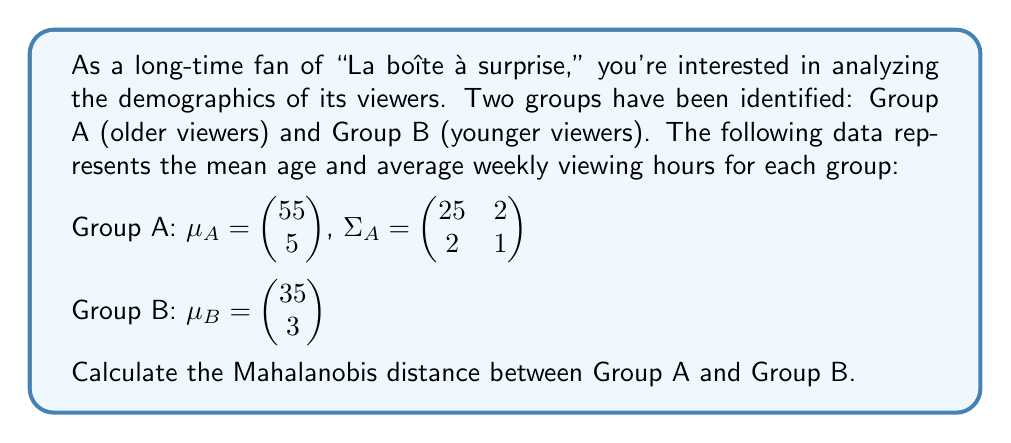Can you solve this math problem? To calculate the Mahalanobis distance between two groups, we'll follow these steps:

1) The Mahalanobis distance formula is:
   $$D_M = \sqrt{(\mu_A - \mu_B)^T \Sigma_A^{-1} (\mu_A - \mu_B)}$$

2) First, calculate $(\mu_A - \mu_B)$:
   $$\mu_A - \mu_B = \begin{pmatrix} 55 \\ 5 \end{pmatrix} - \begin{pmatrix} 35 \\ 3 \end{pmatrix} = \begin{pmatrix} 20 \\ 2 \end{pmatrix}$$

3) Next, we need to find $\Sigma_A^{-1}$. For a 2x2 matrix $\begin{pmatrix} a & b \\ c & d \end{pmatrix}$, the inverse is:
   $$\frac{1}{ad-bc} \begin{pmatrix} d & -b \\ -c & a \end{pmatrix}$$

   So, $\Sigma_A^{-1} = \frac{1}{25-4} \begin{pmatrix} 1 & -2 \\ -2 & 25 \end{pmatrix} = \frac{1}{21} \begin{pmatrix} 1 & -2 \\ -2 & 25 \end{pmatrix}$

4) Now, calculate $(\mu_A - \mu_B)^T \Sigma_A^{-1} (\mu_A - \mu_B)$:
   $$\begin{pmatrix} 20 & 2 \end{pmatrix} \frac{1}{21} \begin{pmatrix} 1 & -2 \\ -2 & 25 \end{pmatrix} \begin{pmatrix} 20 \\ 2 \end{pmatrix}$$

5) Multiply the matrices:
   $$\frac{1}{21} \begin{pmatrix} 20 & 2 \end{pmatrix} \begin{pmatrix} 20 - 4 \\ -40 + 50 \end{pmatrix} = \frac{1}{21} (320 + 20) = \frac{340}{21}$$

6) Finally, take the square root:
   $$D_M = \sqrt{\frac{340}{21}} \approx 4.02$$
Answer: $4.02$ 